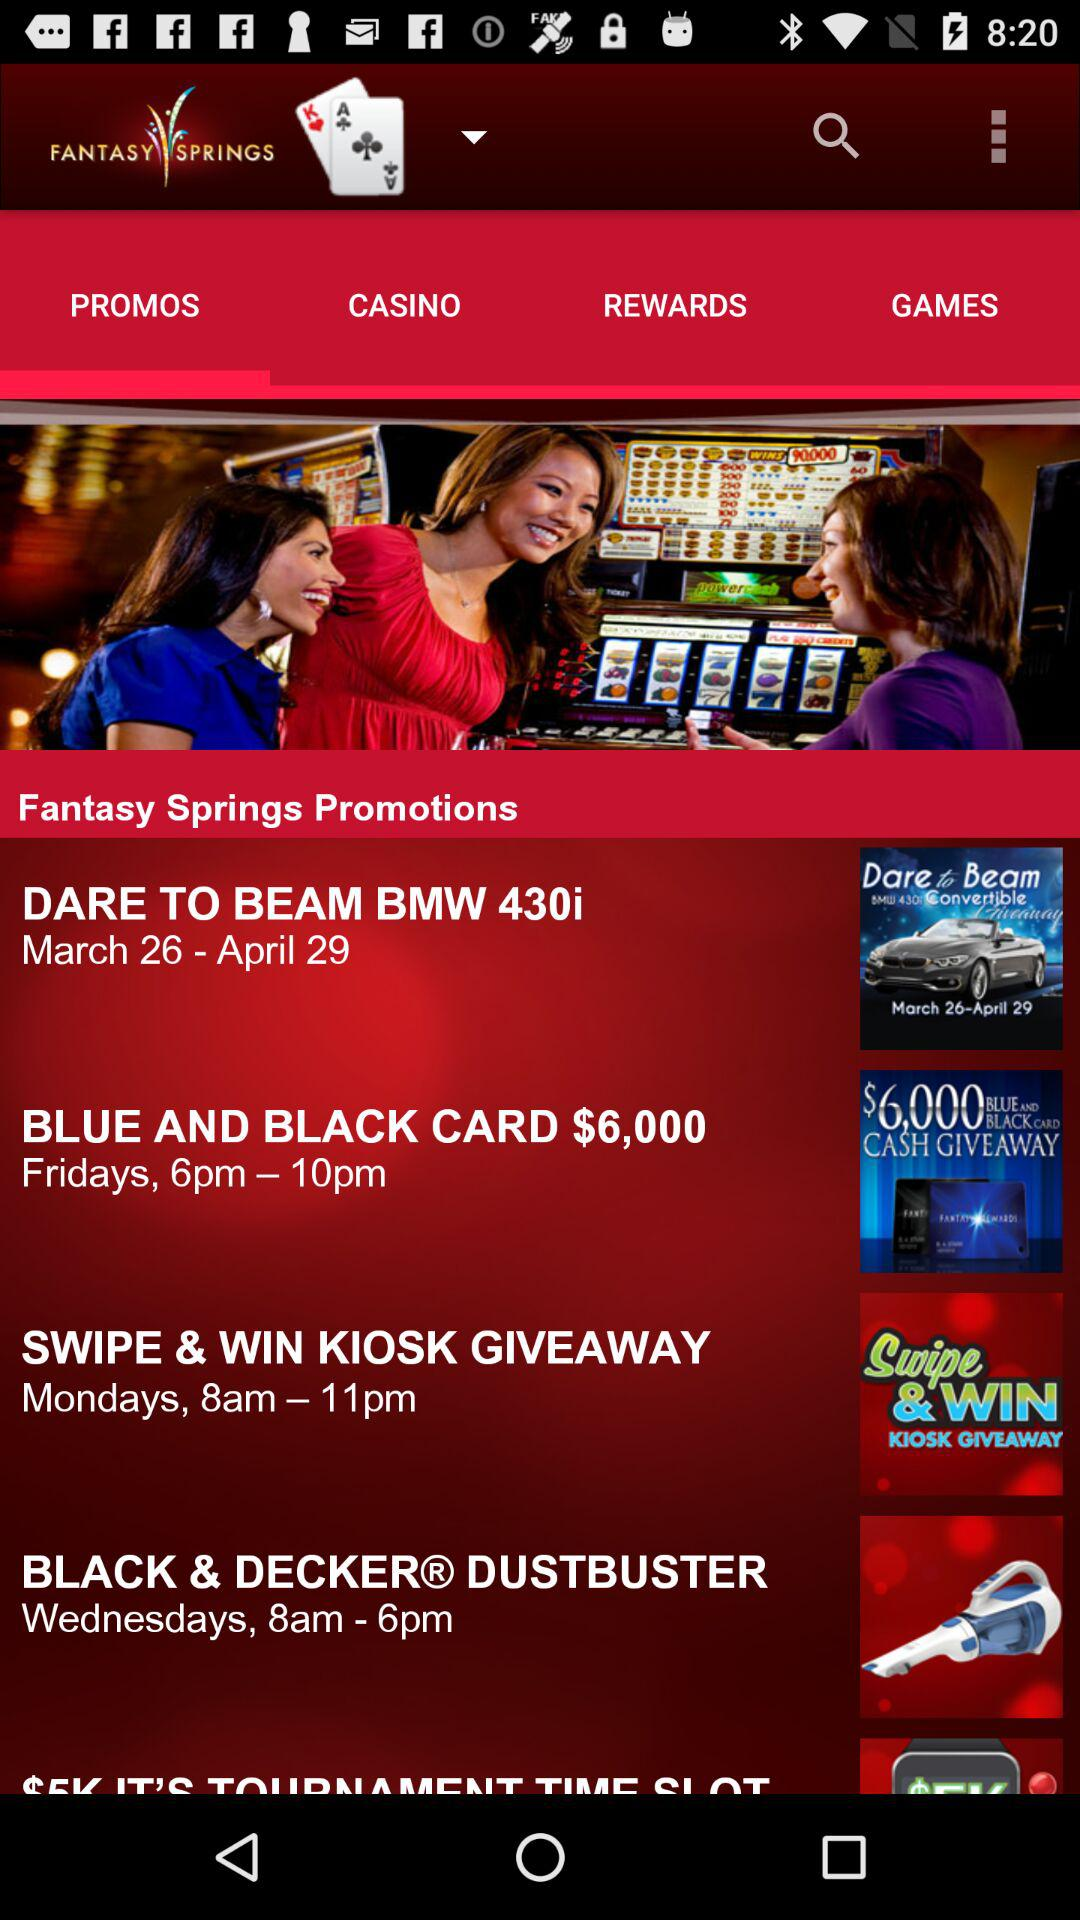What is the giveaway amount for the blue and black cards? The amount is 6,000 dollars. 